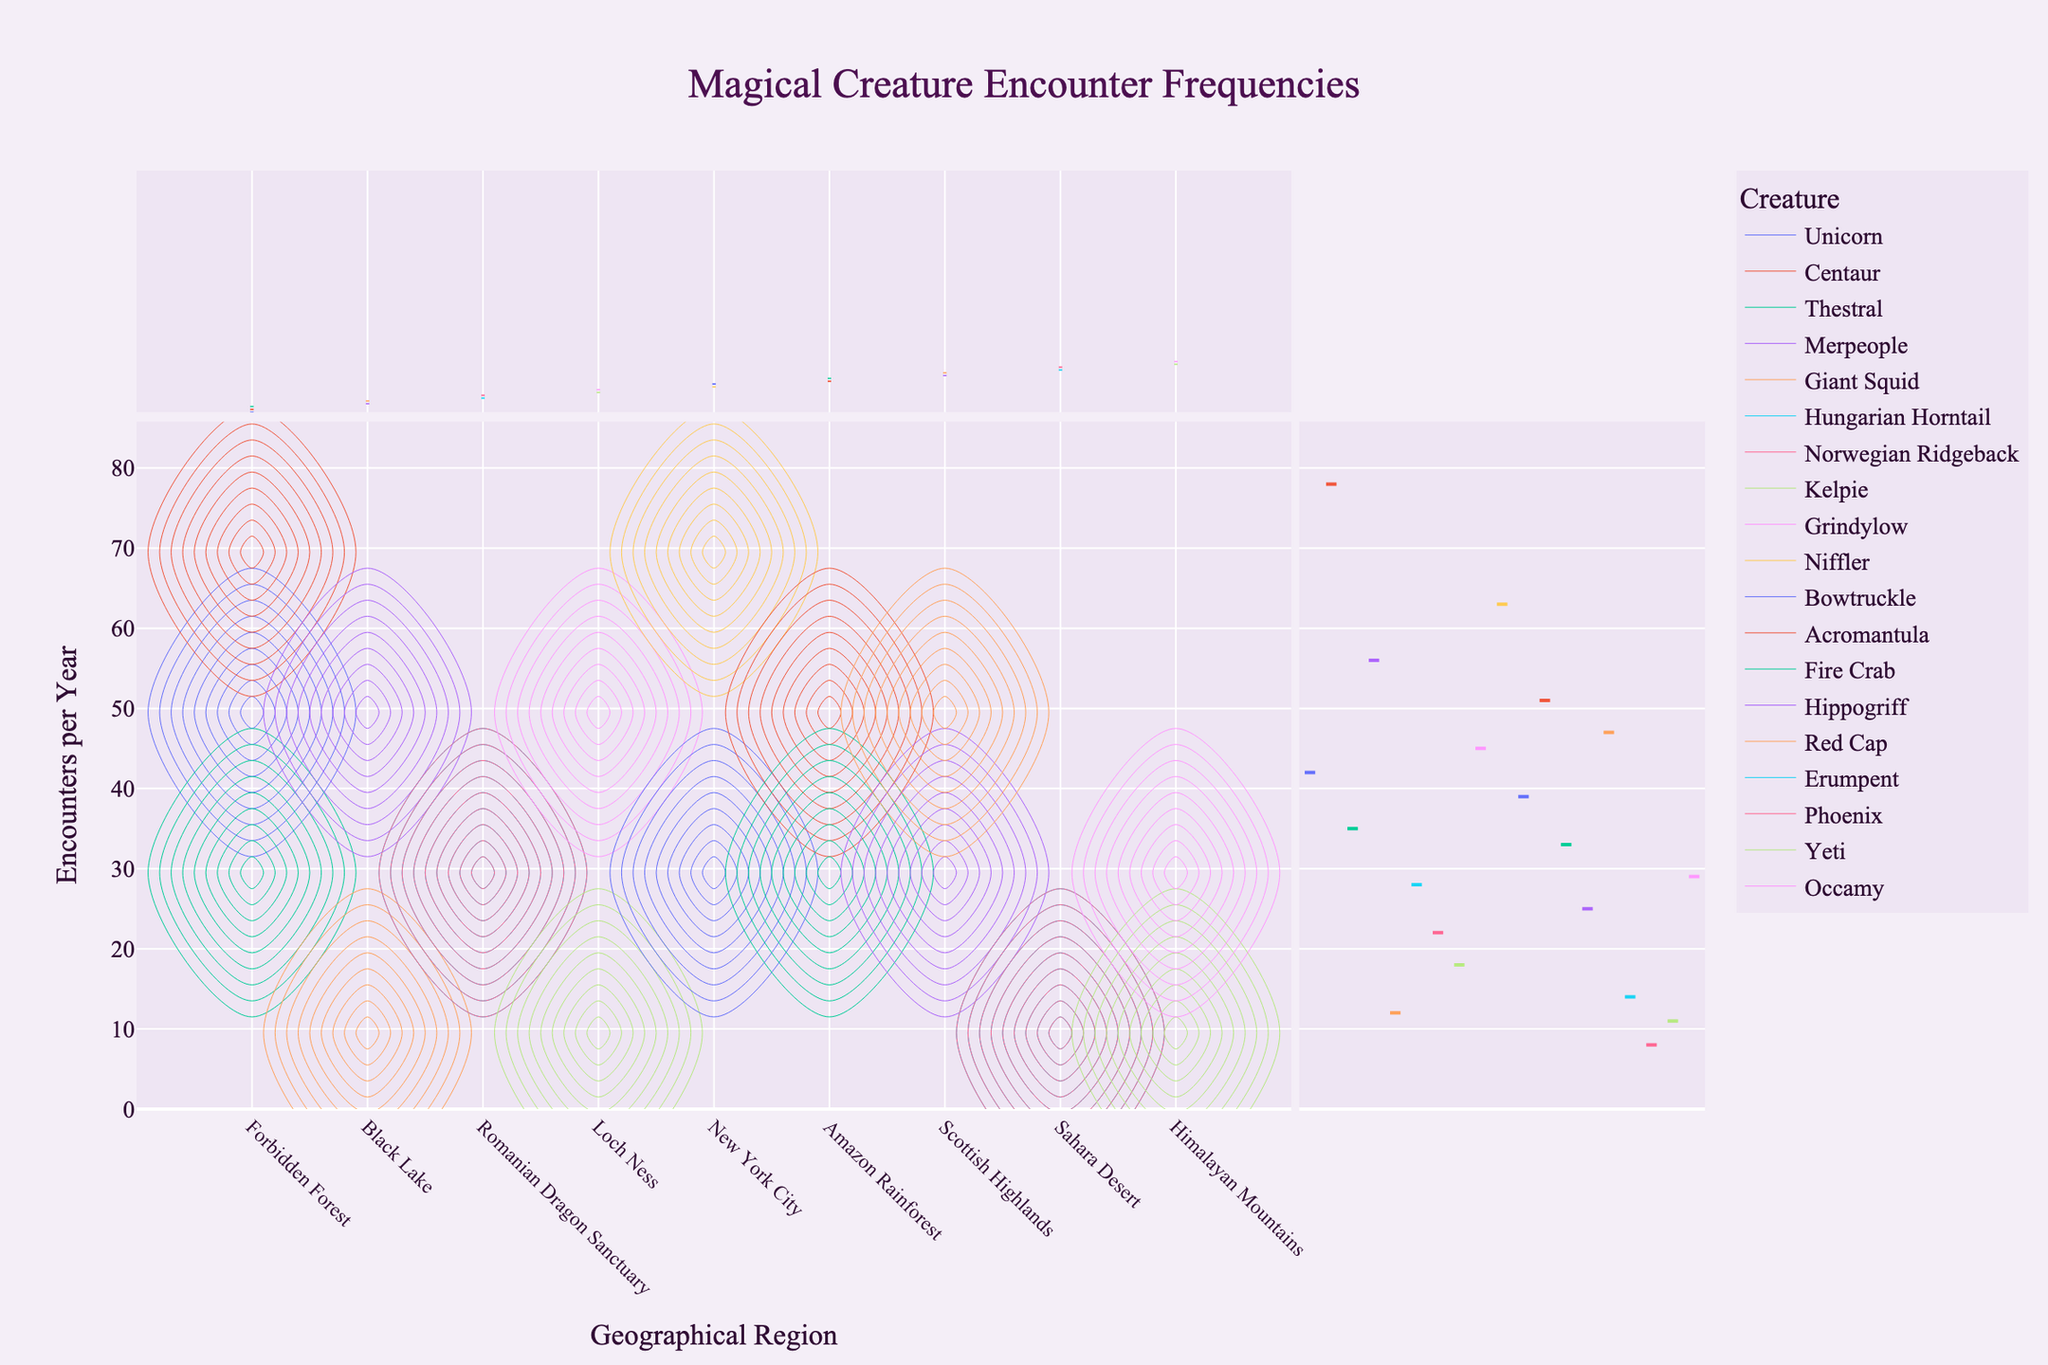What's the title of the figure? The title is found at the top center of the figure. It gives an overview of what the plot represents.
Answer: Magical Creature Encounter Frequencies Which region has the highest number of encounters with Nifflers? By looking at the "Region" and "Encounters per Year" axes, identify the point where a high number of encounters is associated with Nifflers.
Answer: New York City How many encounters with magical creatures occur annually in the Forbidden Forest? Sum all the encounter frequencies for the Forbidden Forest. The data points corresponding to Forbidden Forest should be identified and added together.
Answer: 42 + 78 + 35 = 155 Which creature in the Black Lake has a lower number of yearly encounters, and by how much? Compare the encounter frequencies of Merpeople and Giant Squid in the Black Lake region and subtract the lower value from the higher value.
Answer: Giant Squid, by 44 encounters Are there more encounter frequencies with unicorns or acromantulas, and in which regions do these encounters occur? Compare the unicorn and acromantula encounter data points by examining their frequencies on the plot and identify their respective regions.
Answer: More encounters with unicorns (Forbidden Forest). Acromantulas are in the Amazon Rainforest Which region has the overall lowest number of magical creature encounters, and how many encounters are there? Identify the region with the smallest sum of encounters by adding the encounter frequencies of all creatures in each region and finding the minimum.
Answer: Sahara Desert, 22 encounters What is the range of encounters per year for creatures in the Himalayan Mountains? Find the minimum and maximum values of encounter frequencies in the Himalayan Mountains and calculate the difference.
Answer: 11 to 29, range is 18 Compare the average encounter frequencies of creatures between Forbidden Forest and New York City. Which region has a higher average? Calculate the average encounters per year for creatures in both regions by summing their encounters and dividing by the number of species, then compare the two averages.
Answer: Forbidden Forest (average ~51.7) vs. New York City (average ~51). Forbidden Forest has a higher average How does the density contour distribution for Loch Ness compare with that of the Romanian Dragon Sanctuary? Analyze the density of contours (i.e., concentration of data points) and compare the spread and intensity between the two regions.
Answer: Loch Ness shows denser contours, indicating more concentrated encounters What's the sum of yearly encounters with creatures in two regions combined: the Forbidden Forest and the Amazon Rainforest? Add the yearly encounters of creatures in both regions.
Answer: 155 (Forbidden Forest) + 84 (Amazon Rainforest) = 239 